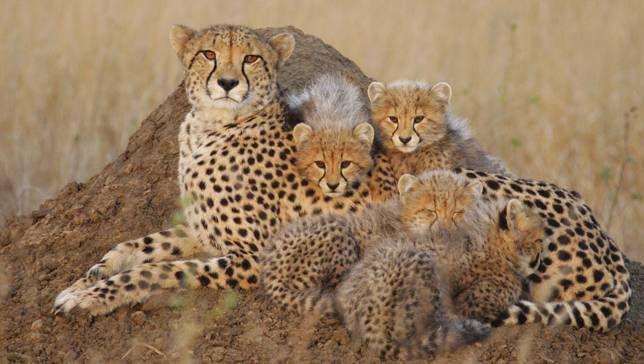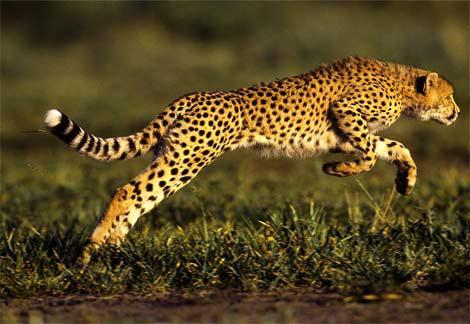The first image is the image on the left, the second image is the image on the right. For the images displayed, is the sentence "An image depicts just one cheetah, which is in a leaping pose." factually correct? Answer yes or no. Yes. 